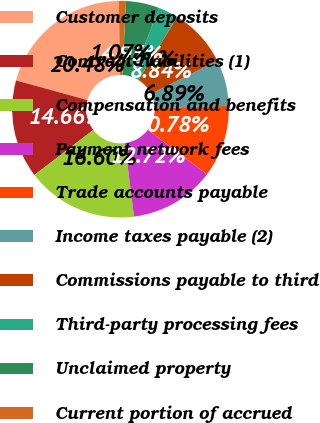Convert chart to OTSL. <chart><loc_0><loc_0><loc_500><loc_500><pie_chart><fcel>Customer deposits<fcel>Contract liabilities (1)<fcel>Compensation and benefits<fcel>Payment network fees<fcel>Trade accounts payable<fcel>Income taxes payable (2)<fcel>Commissions payable to third<fcel>Third-party processing fees<fcel>Unclaimed property<fcel>Current portion of accrued<nl><fcel>20.48%<fcel>14.66%<fcel>16.6%<fcel>12.72%<fcel>10.78%<fcel>6.89%<fcel>8.84%<fcel>3.01%<fcel>4.95%<fcel>1.07%<nl></chart> 